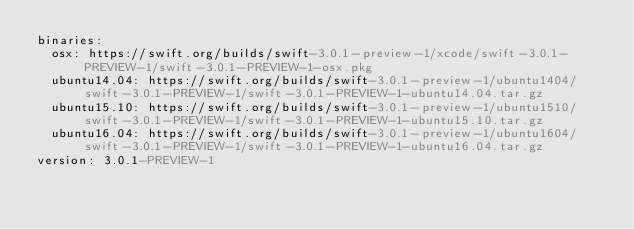<code> <loc_0><loc_0><loc_500><loc_500><_YAML_>binaries:
  osx: https://swift.org/builds/swift-3.0.1-preview-1/xcode/swift-3.0.1-PREVIEW-1/swift-3.0.1-PREVIEW-1-osx.pkg
  ubuntu14.04: https://swift.org/builds/swift-3.0.1-preview-1/ubuntu1404/swift-3.0.1-PREVIEW-1/swift-3.0.1-PREVIEW-1-ubuntu14.04.tar.gz
  ubuntu15.10: https://swift.org/builds/swift-3.0.1-preview-1/ubuntu1510/swift-3.0.1-PREVIEW-1/swift-3.0.1-PREVIEW-1-ubuntu15.10.tar.gz
  ubuntu16.04: https://swift.org/builds/swift-3.0.1-preview-1/ubuntu1604/swift-3.0.1-PREVIEW-1/swift-3.0.1-PREVIEW-1-ubuntu16.04.tar.gz
version: 3.0.1-PREVIEW-1
</code> 